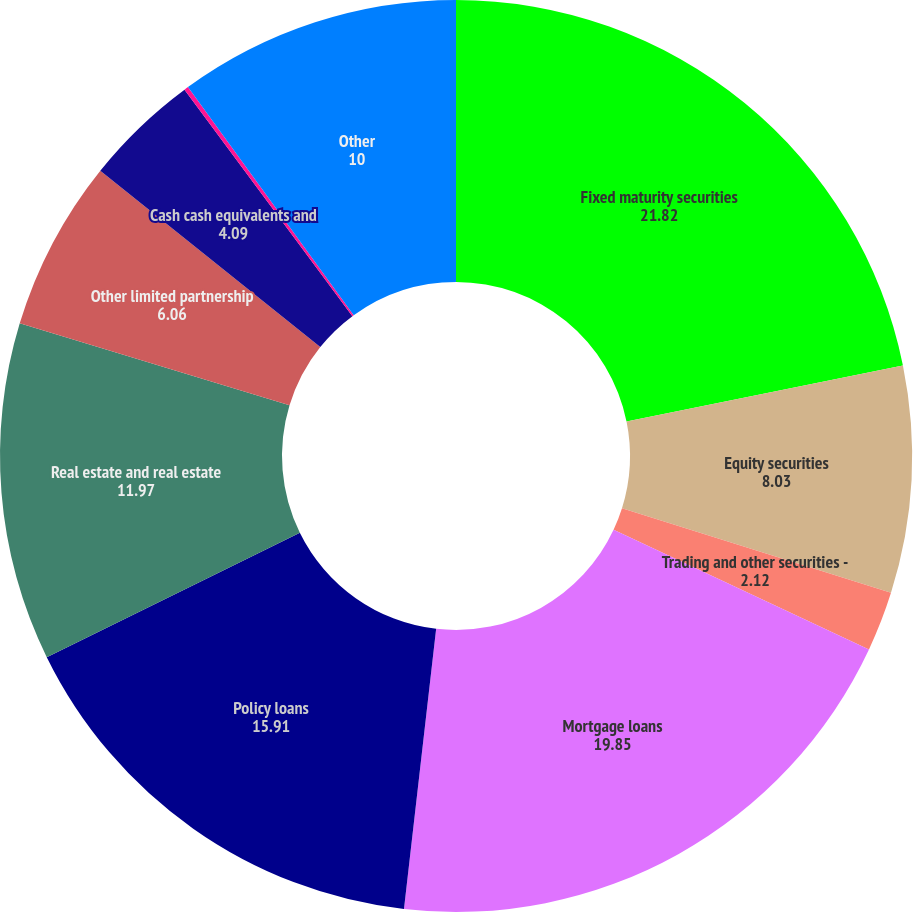Convert chart. <chart><loc_0><loc_0><loc_500><loc_500><pie_chart><fcel>Fixed maturity securities<fcel>Equity securities<fcel>Trading and other securities -<fcel>Mortgage loans<fcel>Policy loans<fcel>Real estate and real estate<fcel>Other limited partnership<fcel>Cash cash equivalents and<fcel>International joint<fcel>Other<nl><fcel>21.82%<fcel>8.03%<fcel>2.12%<fcel>19.85%<fcel>15.91%<fcel>11.97%<fcel>6.06%<fcel>4.09%<fcel>0.15%<fcel>10.0%<nl></chart> 